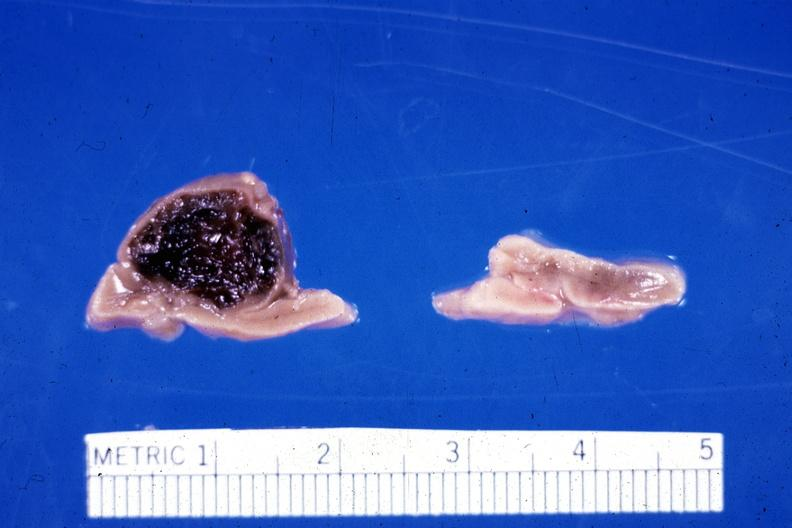what does this image show?
Answer the question using a single word or phrase. Fixed tissue hemorrhage hematoma in left adrenal of premature 30 week gestation gram infant lesion had ruptured causing 20 ml hemoperitoneum unusual lesion 